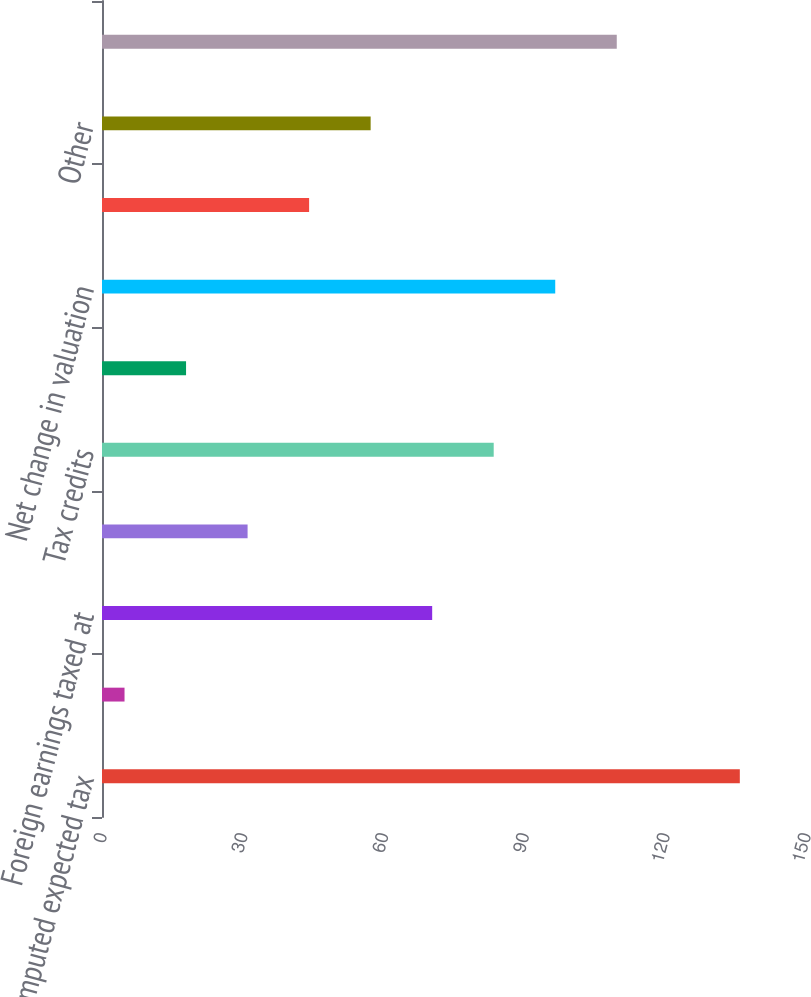Convert chart. <chart><loc_0><loc_0><loc_500><loc_500><bar_chart><fcel>Computed expected tax<fcel>State income taxes net of<fcel>Foreign earnings taxed at<fcel>US tax on foreign earnings<fcel>Tax credits<fcel>Withholding tax<fcel>Net change in valuation<fcel>Net change in unrecognized tax<fcel>Other<fcel>Income tax expense and rate<nl><fcel>135.9<fcel>4.8<fcel>70.35<fcel>31.02<fcel>83.46<fcel>17.91<fcel>96.57<fcel>44.13<fcel>57.24<fcel>109.68<nl></chart> 